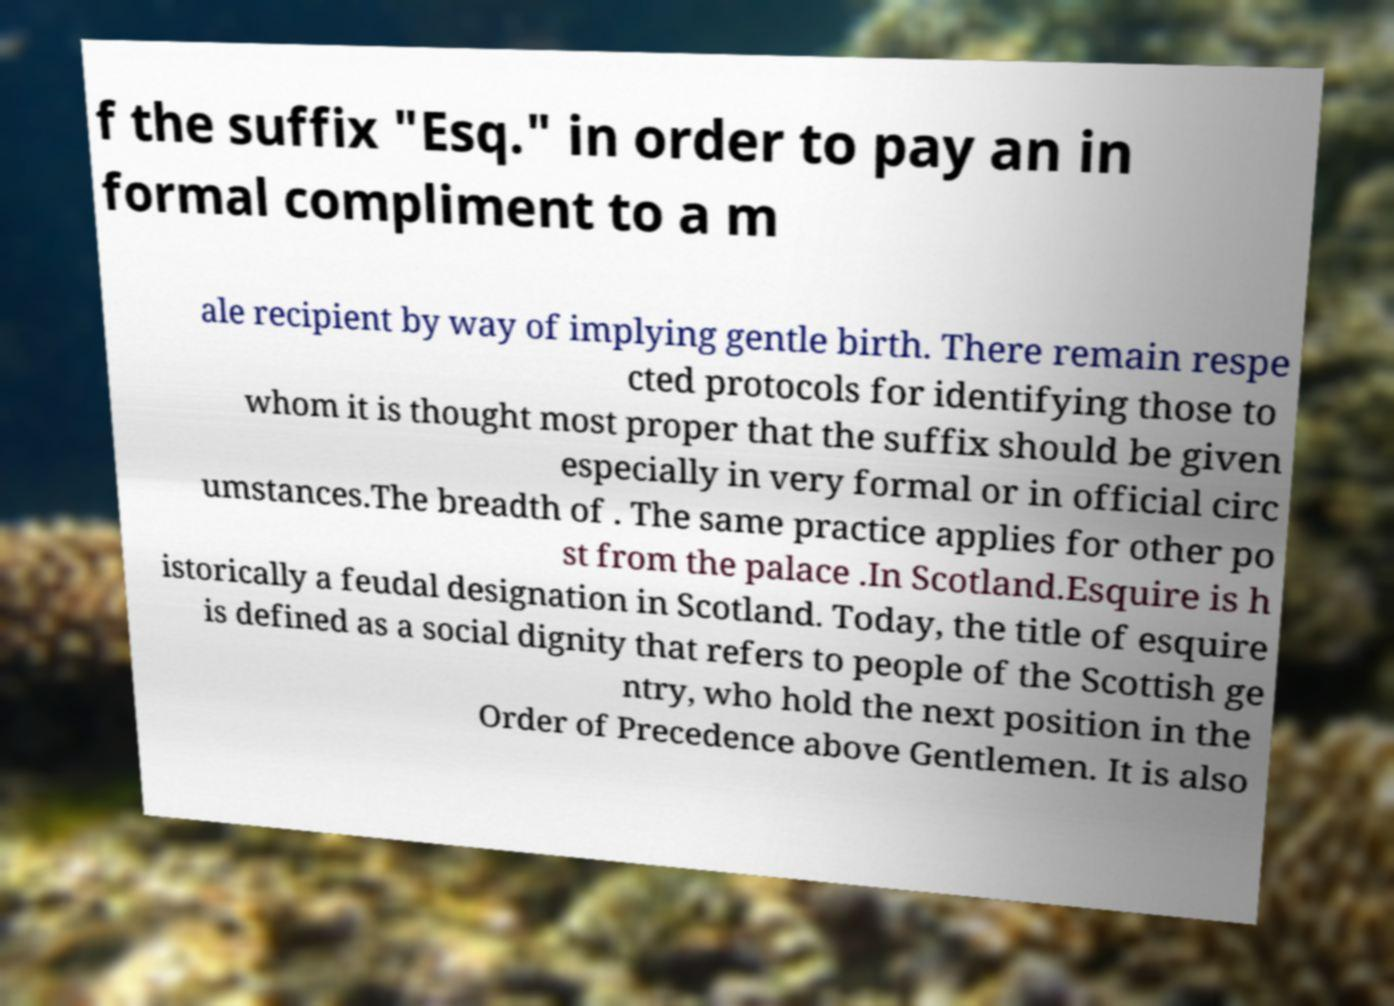There's text embedded in this image that I need extracted. Can you transcribe it verbatim? f the suffix "Esq." in order to pay an in formal compliment to a m ale recipient by way of implying gentle birth. There remain respe cted protocols for identifying those to whom it is thought most proper that the suffix should be given especially in very formal or in official circ umstances.The breadth of . The same practice applies for other po st from the palace .In Scotland.Esquire is h istorically a feudal designation in Scotland. Today, the title of esquire is defined as a social dignity that refers to people of the Scottish ge ntry, who hold the next position in the Order of Precedence above Gentlemen. It is also 